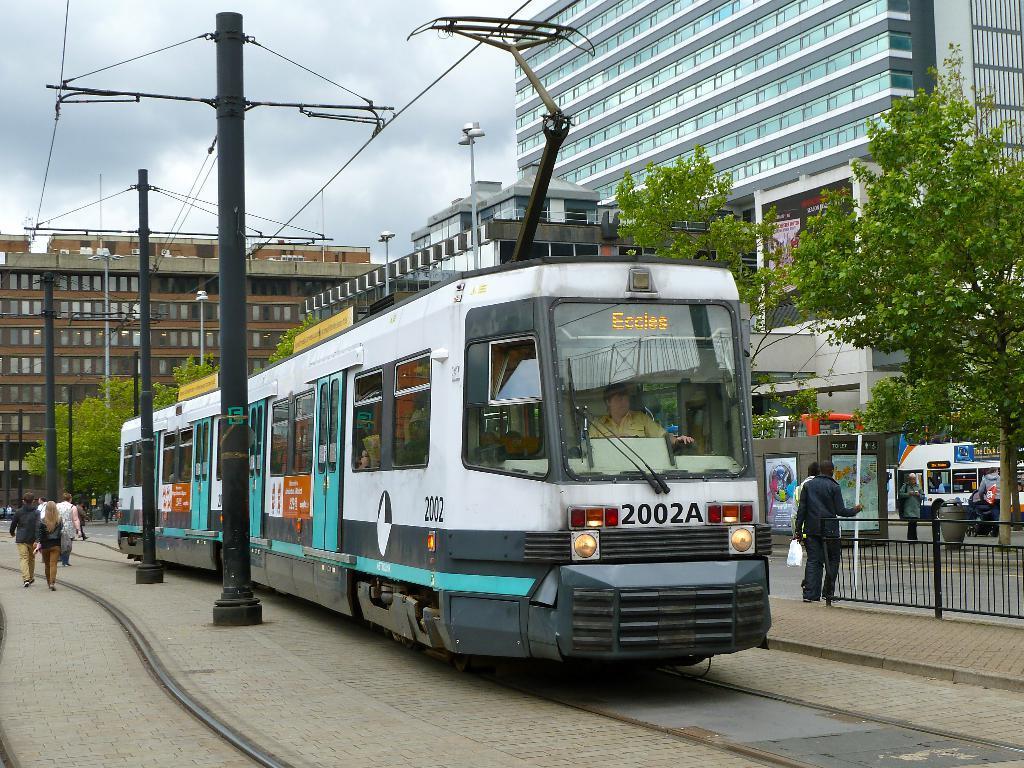Could you give a brief overview of what you see in this image? In the center of the image, we can see a train and in the background, there are people walking and we can see trees, buildings, poles along with wires and there are some other vehicles. 